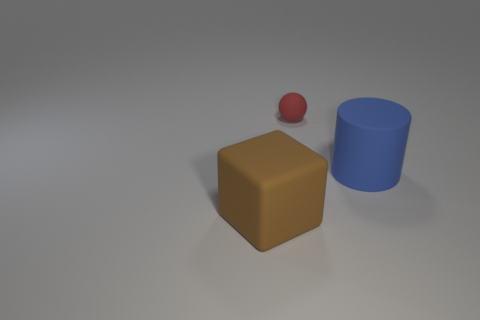There is a thing that is both behind the block and in front of the tiny red matte thing; what is its color?
Ensure brevity in your answer.  Blue. How many cubes are small cyan rubber things or large blue matte objects?
Provide a short and direct response. 0. There is a object that is the same size as the brown matte cube; what is its color?
Offer a very short reply. Blue. Is there a red rubber sphere that is right of the big rubber thing to the left of the big thing that is behind the brown matte thing?
Give a very brief answer. Yes. How big is the brown block?
Give a very brief answer. Large. How many things are either red metal cylinders or matte things?
Your answer should be very brief. 3. The small object that is made of the same material as the large cylinder is what color?
Your answer should be compact. Red. There is a large object to the right of the brown cube; is its shape the same as the large brown object?
Give a very brief answer. No. How many things are big objects that are left of the big blue cylinder or big objects in front of the big blue matte cylinder?
Offer a terse response. 1. What is the cylinder made of?
Make the answer very short. Rubber. 